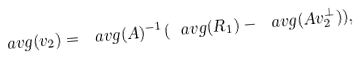<formula> <loc_0><loc_0><loc_500><loc_500>\ a v g ( v _ { 2 } ) = \ a v g ( A ) ^ { - 1 } ( \ a v g ( R _ { 1 } ) - \ a v g ( A v ^ { \perp } _ { 2 } ) ) ,</formula> 